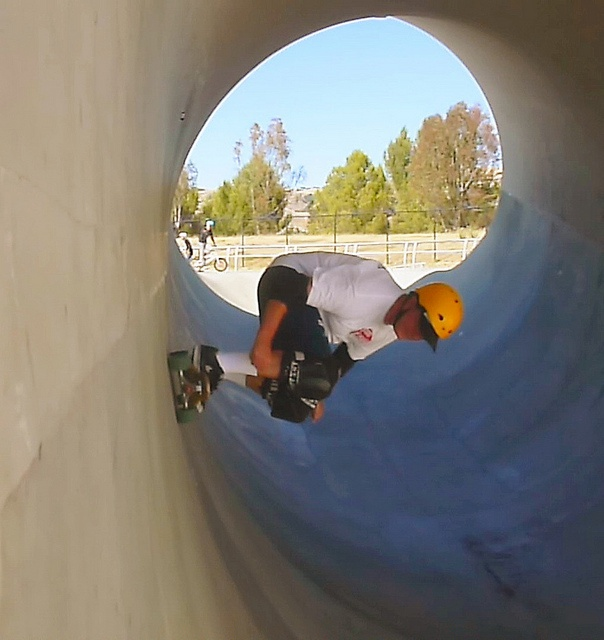Describe the objects in this image and their specific colors. I can see people in tan, black, darkgray, maroon, and brown tones, skateboard in tan, black, darkgreen, and gray tones, bicycle in tan and ivory tones, people in tan, white, gray, and darkgray tones, and people in tan, white, black, gray, and darkgray tones in this image. 